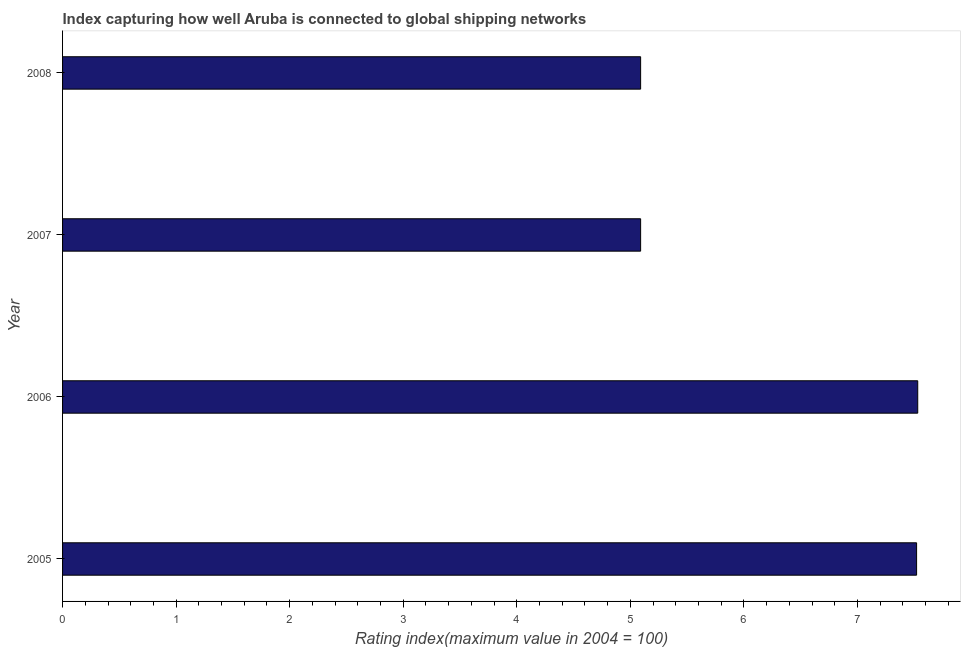Does the graph contain grids?
Offer a very short reply. No. What is the title of the graph?
Give a very brief answer. Index capturing how well Aruba is connected to global shipping networks. What is the label or title of the X-axis?
Your response must be concise. Rating index(maximum value in 2004 = 100). What is the liner shipping connectivity index in 2007?
Offer a very short reply. 5.09. Across all years, what is the maximum liner shipping connectivity index?
Make the answer very short. 7.53. Across all years, what is the minimum liner shipping connectivity index?
Ensure brevity in your answer.  5.09. In which year was the liner shipping connectivity index maximum?
Ensure brevity in your answer.  2006. What is the sum of the liner shipping connectivity index?
Offer a terse response. 25.23. What is the difference between the liner shipping connectivity index in 2007 and 2008?
Give a very brief answer. 0. What is the average liner shipping connectivity index per year?
Your answer should be compact. 6.31. What is the median liner shipping connectivity index?
Give a very brief answer. 6.3. In how many years, is the liner shipping connectivity index greater than 0.2 ?
Ensure brevity in your answer.  4. Do a majority of the years between 2006 and 2007 (inclusive) have liner shipping connectivity index greater than 0.2 ?
Provide a short and direct response. Yes. What is the ratio of the liner shipping connectivity index in 2005 to that in 2008?
Your answer should be very brief. 1.48. Is the liner shipping connectivity index in 2007 less than that in 2008?
Your answer should be very brief. No. Is the difference between the liner shipping connectivity index in 2005 and 2007 greater than the difference between any two years?
Your answer should be very brief. No. What is the difference between the highest and the second highest liner shipping connectivity index?
Ensure brevity in your answer.  0.01. What is the difference between the highest and the lowest liner shipping connectivity index?
Your answer should be compact. 2.44. How many bars are there?
Ensure brevity in your answer.  4. Are all the bars in the graph horizontal?
Make the answer very short. Yes. What is the Rating index(maximum value in 2004 = 100) of 2005?
Provide a short and direct response. 7.52. What is the Rating index(maximum value in 2004 = 100) in 2006?
Provide a succinct answer. 7.53. What is the Rating index(maximum value in 2004 = 100) in 2007?
Provide a short and direct response. 5.09. What is the Rating index(maximum value in 2004 = 100) in 2008?
Provide a short and direct response. 5.09. What is the difference between the Rating index(maximum value in 2004 = 100) in 2005 and 2006?
Keep it short and to the point. -0.01. What is the difference between the Rating index(maximum value in 2004 = 100) in 2005 and 2007?
Provide a short and direct response. 2.43. What is the difference between the Rating index(maximum value in 2004 = 100) in 2005 and 2008?
Give a very brief answer. 2.43. What is the difference between the Rating index(maximum value in 2004 = 100) in 2006 and 2007?
Keep it short and to the point. 2.44. What is the difference between the Rating index(maximum value in 2004 = 100) in 2006 and 2008?
Make the answer very short. 2.44. What is the ratio of the Rating index(maximum value in 2004 = 100) in 2005 to that in 2006?
Offer a terse response. 1. What is the ratio of the Rating index(maximum value in 2004 = 100) in 2005 to that in 2007?
Make the answer very short. 1.48. What is the ratio of the Rating index(maximum value in 2004 = 100) in 2005 to that in 2008?
Offer a terse response. 1.48. What is the ratio of the Rating index(maximum value in 2004 = 100) in 2006 to that in 2007?
Offer a very short reply. 1.48. What is the ratio of the Rating index(maximum value in 2004 = 100) in 2006 to that in 2008?
Give a very brief answer. 1.48. 